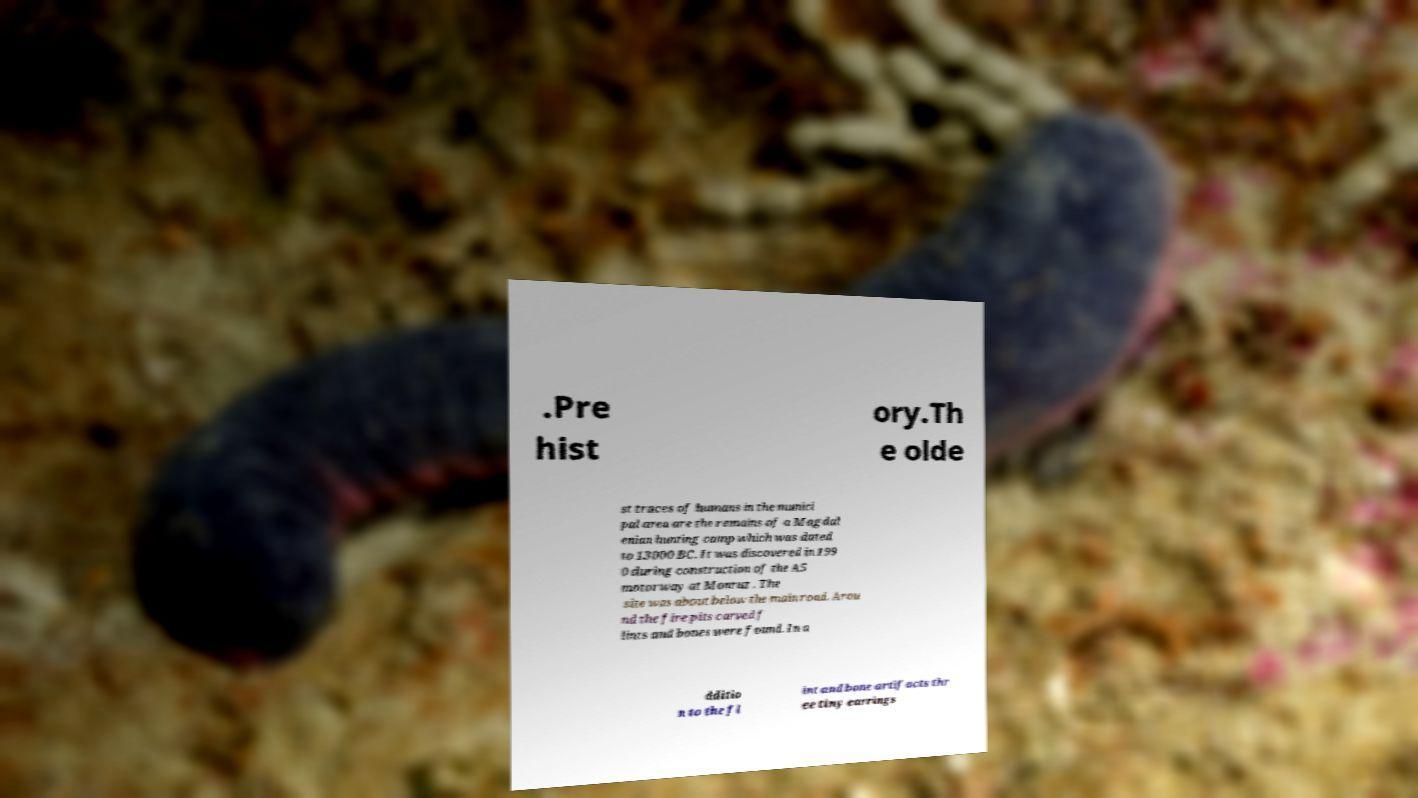I need the written content from this picture converted into text. Can you do that? .Pre hist ory.Th e olde st traces of humans in the munici pal area are the remains of a Magdal enian hunting camp which was dated to 13000 BC. It was discovered in 199 0 during construction of the A5 motorway at Monruz . The site was about below the main road. Arou nd the fire pits carved f lints and bones were found. In a dditio n to the fl int and bone artifacts thr ee tiny earrings 